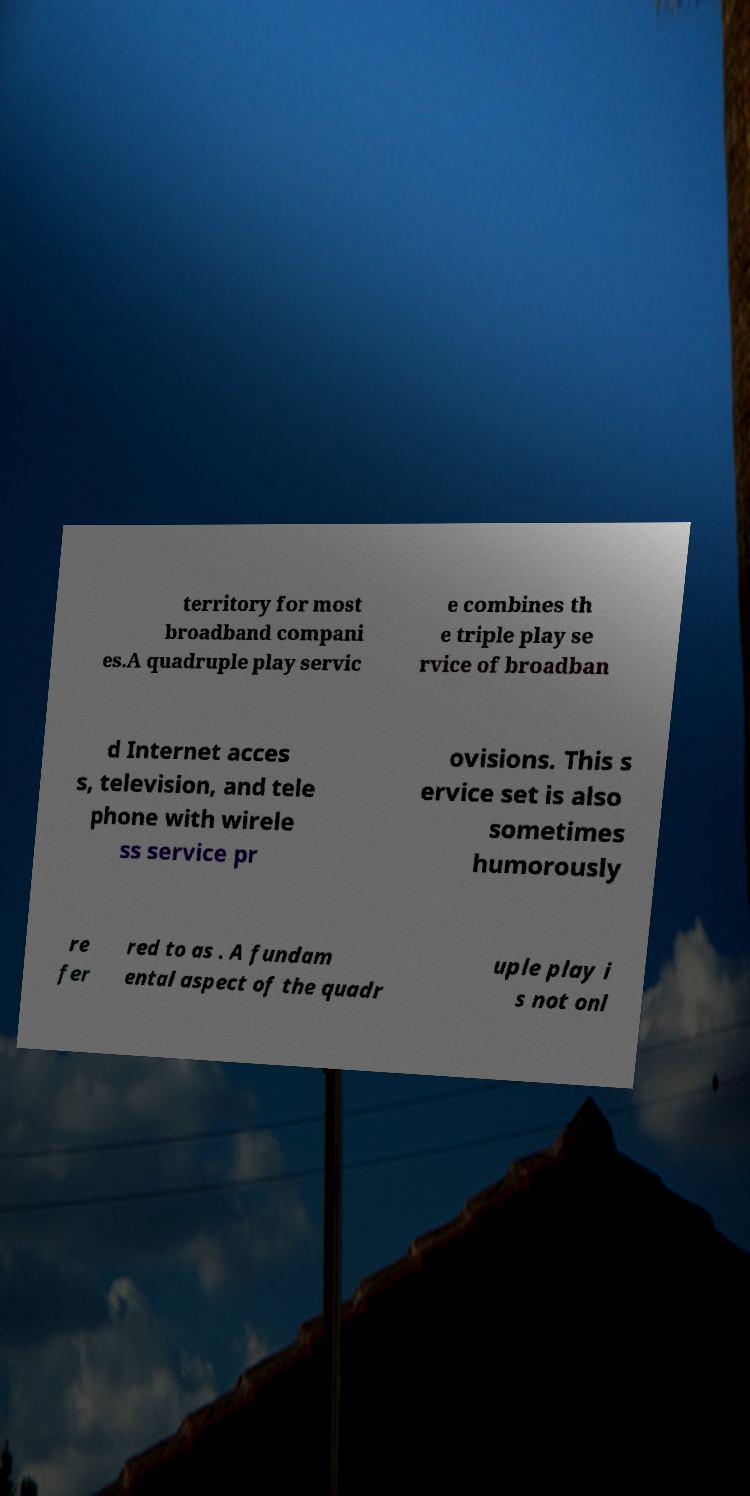For documentation purposes, I need the text within this image transcribed. Could you provide that? territory for most broadband compani es.A quadruple play servic e combines th e triple play se rvice of broadban d Internet acces s, television, and tele phone with wirele ss service pr ovisions. This s ervice set is also sometimes humorously re fer red to as . A fundam ental aspect of the quadr uple play i s not onl 